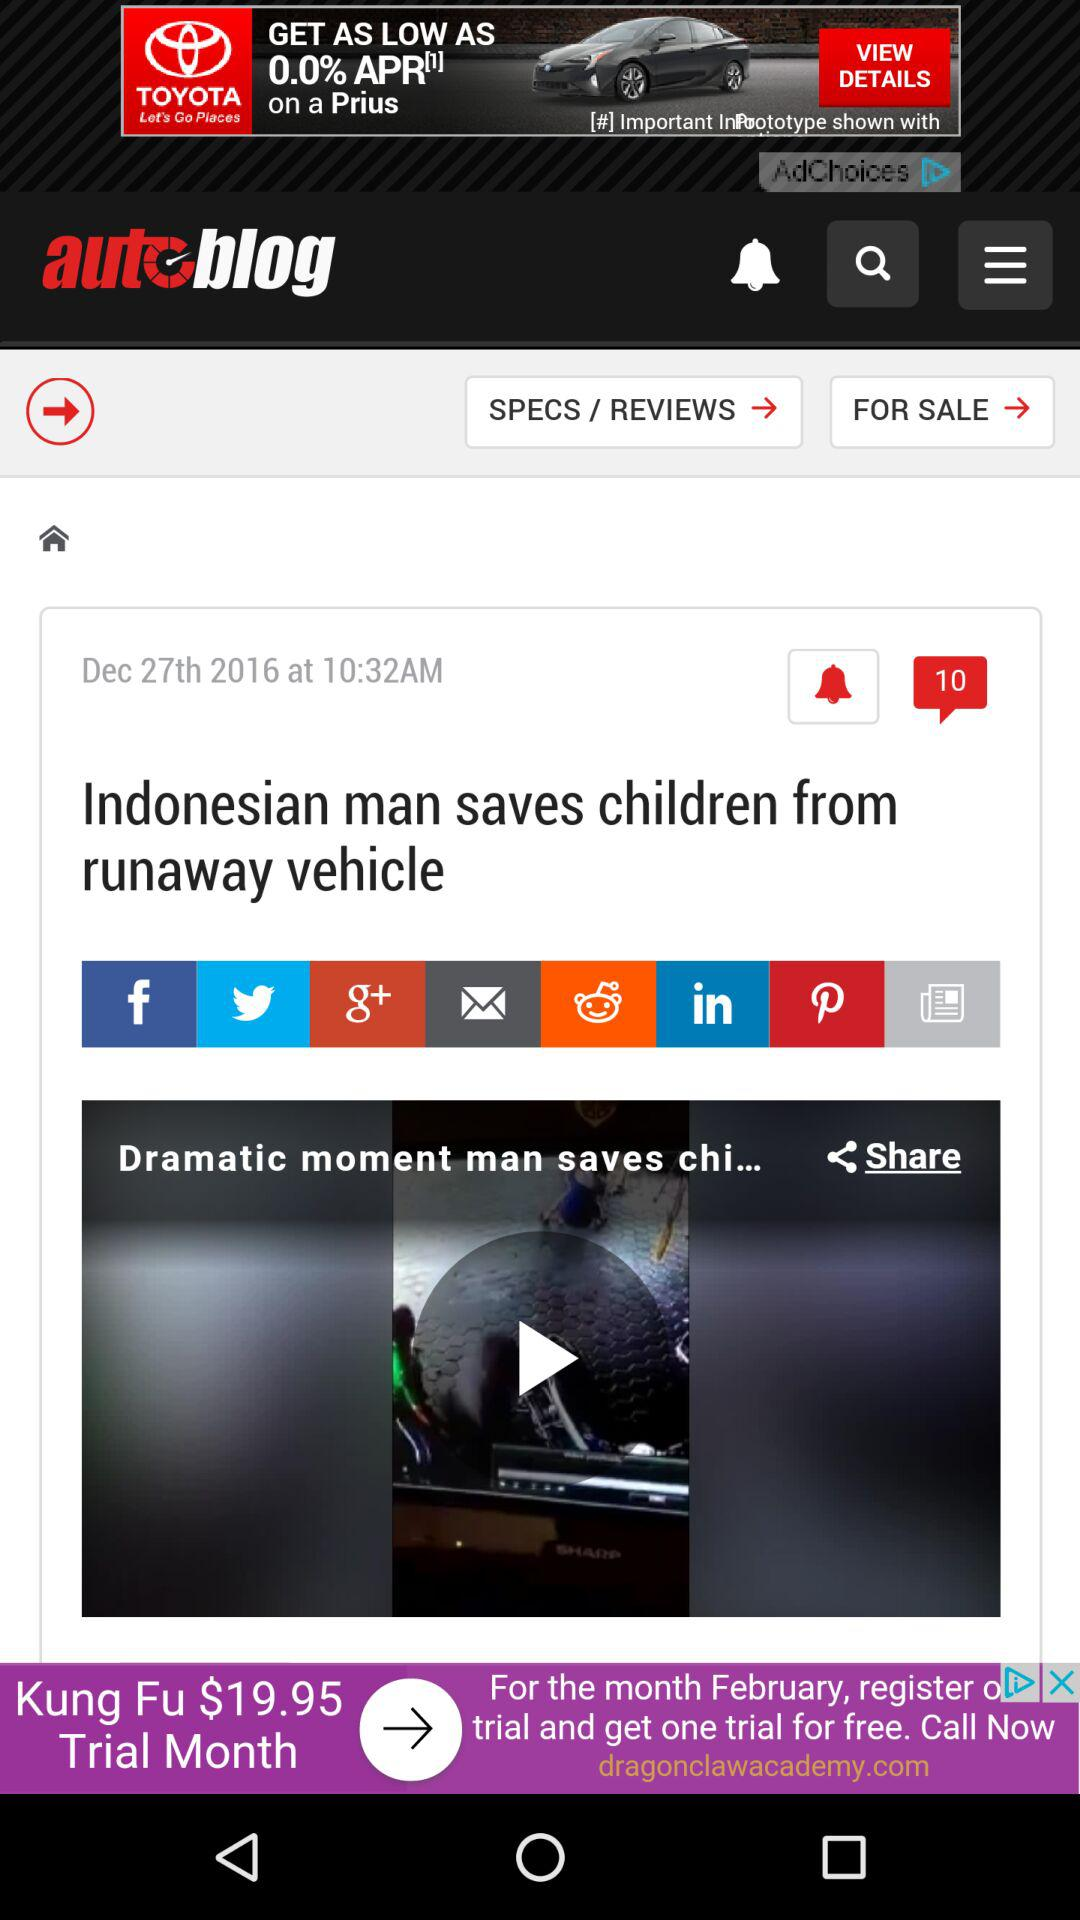What is the published time of the article? The published time of the article is 10:32 AM. 